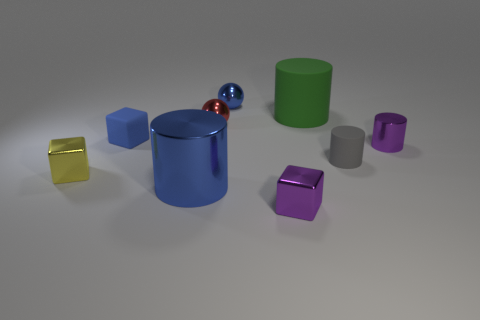Subtract all purple cubes. How many cubes are left? 2 Subtract all blue blocks. How many blocks are left? 2 Subtract all cubes. How many objects are left? 6 Subtract all blue blocks. Subtract all gray cylinders. How many blocks are left? 2 Subtract all green cubes. How many cyan balls are left? 0 Subtract all red shiny things. Subtract all blue metal cylinders. How many objects are left? 7 Add 7 tiny blue metal objects. How many tiny blue metal objects are left? 8 Add 5 cyan rubber cubes. How many cyan rubber cubes exist? 5 Subtract 0 gray balls. How many objects are left? 9 Subtract 2 spheres. How many spheres are left? 0 